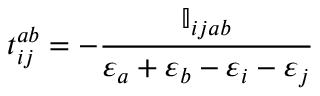<formula> <loc_0><loc_0><loc_500><loc_500>t _ { i j } ^ { a b } = - \frac { \mathbb { I } _ { i j a b } } { \varepsilon _ { a } + \varepsilon _ { b } - \varepsilon _ { i } - \varepsilon _ { j } }</formula> 